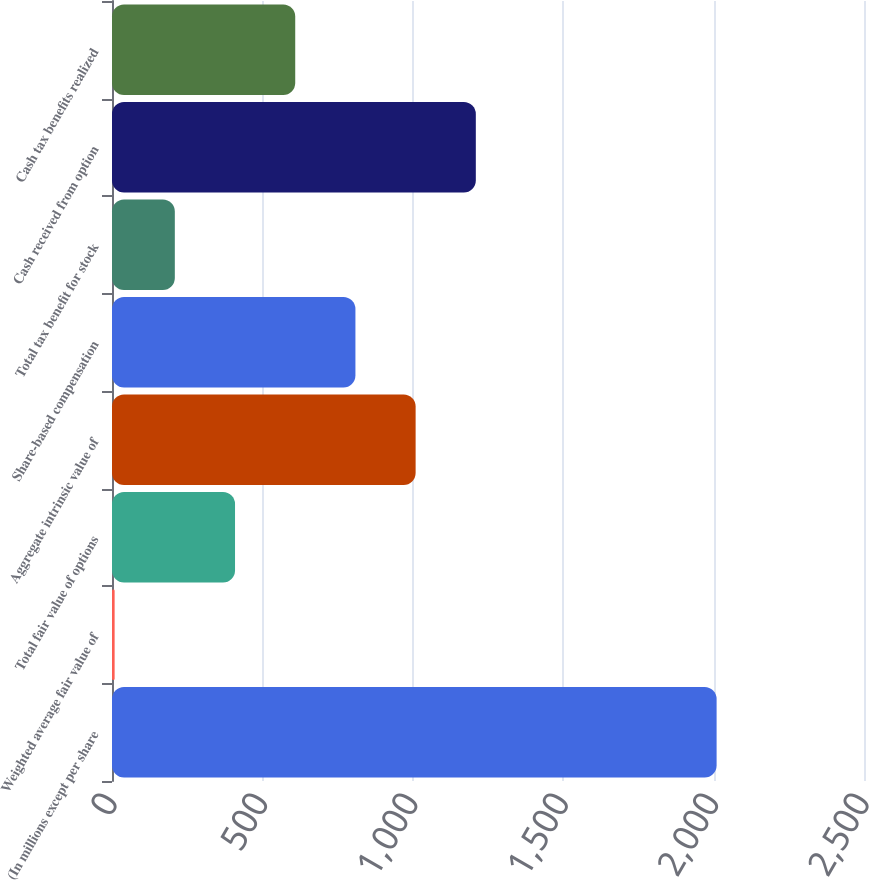Convert chart. <chart><loc_0><loc_0><loc_500><loc_500><bar_chart><fcel>(In millions except per share<fcel>Weighted average fair value of<fcel>Total fair value of options<fcel>Aggregate intrinsic value of<fcel>Share-based compensation<fcel>Total tax benefit for stock<fcel>Cash received from option<fcel>Cash tax benefits realized<nl><fcel>2010<fcel>8.73<fcel>408.99<fcel>1009.38<fcel>809.25<fcel>208.86<fcel>1209.51<fcel>609.12<nl></chart> 